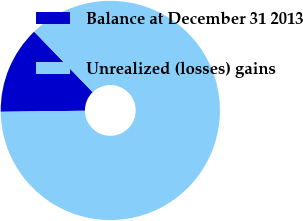<chart> <loc_0><loc_0><loc_500><loc_500><pie_chart><fcel>Balance at December 31 2013<fcel>Unrealized (losses) gains<nl><fcel>12.97%<fcel>87.03%<nl></chart> 